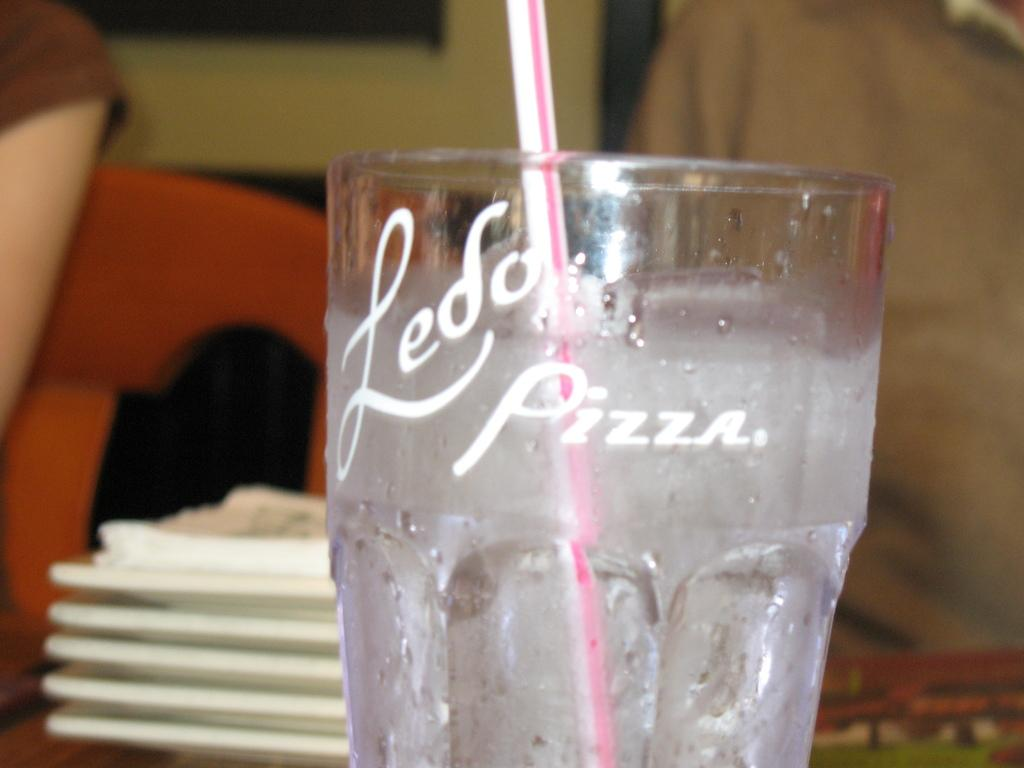<image>
Give a short and clear explanation of the subsequent image. A glass has a straw in it and the word pizza on the side. 